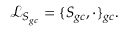<formula> <loc_0><loc_0><loc_500><loc_500>\mathcal { L } _ { S _ { g c } } = \{ S _ { g c } , \cdot \} _ { g c } .</formula> 